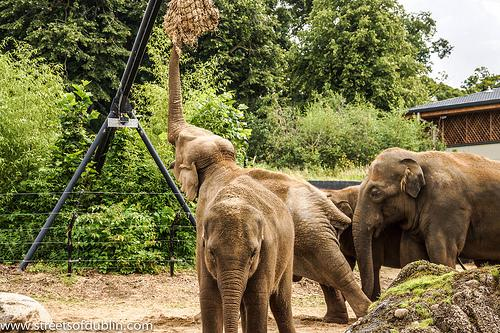Question: what are these animals?
Choices:
A. Zebras.
B. Giraffes.
C. Dogs.
D. Elephants.
Answer with the letter. Answer: D Question: how many elephants are there?
Choices:
A. 3.
B. 2.
C. 1.
D. 4.
Answer with the letter. Answer: D Question: what is on the ground?
Choices:
A. Grass.
B. Sand.
C. Dirt.
D. Concrete.
Answer with the letter. Answer: C 